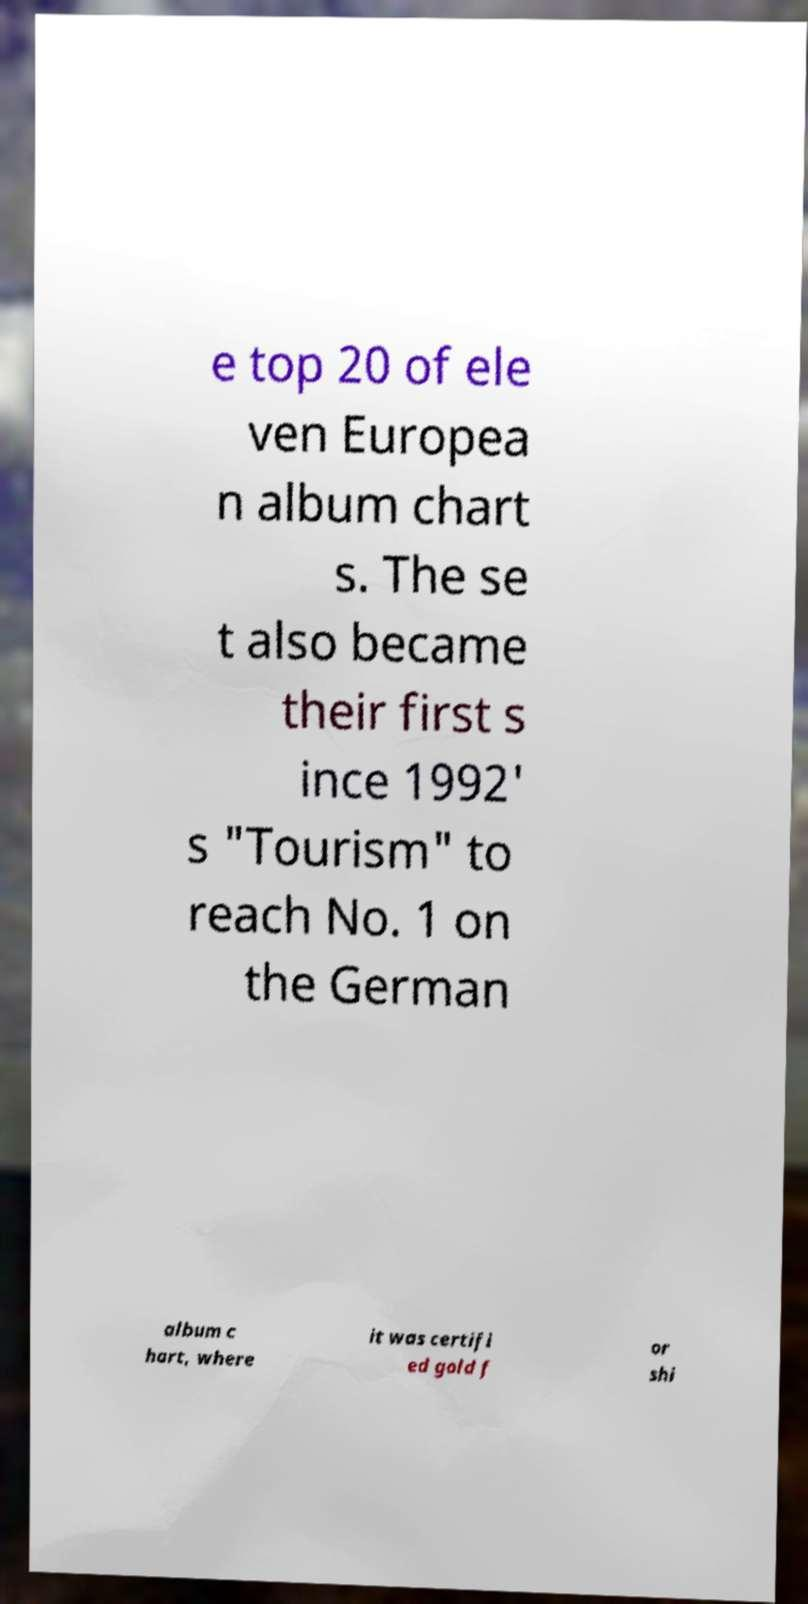What messages or text are displayed in this image? I need them in a readable, typed format. e top 20 of ele ven Europea n album chart s. The se t also became their first s ince 1992' s "Tourism" to reach No. 1 on the German album c hart, where it was certifi ed gold f or shi 